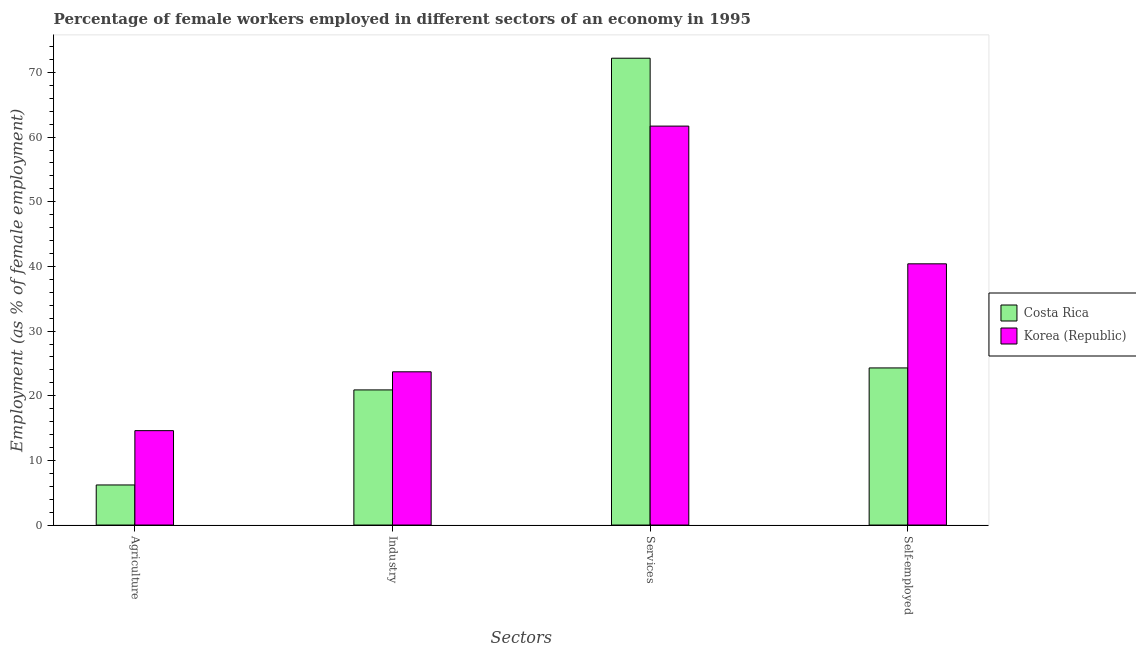How many groups of bars are there?
Your answer should be very brief. 4. Are the number of bars on each tick of the X-axis equal?
Your response must be concise. Yes. How many bars are there on the 2nd tick from the left?
Your answer should be compact. 2. How many bars are there on the 1st tick from the right?
Give a very brief answer. 2. What is the label of the 2nd group of bars from the left?
Provide a short and direct response. Industry. What is the percentage of female workers in services in Costa Rica?
Provide a succinct answer. 72.2. Across all countries, what is the maximum percentage of female workers in agriculture?
Ensure brevity in your answer.  14.6. Across all countries, what is the minimum percentage of female workers in industry?
Keep it short and to the point. 20.9. In which country was the percentage of self employed female workers minimum?
Offer a very short reply. Costa Rica. What is the total percentage of female workers in agriculture in the graph?
Your answer should be compact. 20.8. What is the difference between the percentage of self employed female workers in Korea (Republic) and that in Costa Rica?
Ensure brevity in your answer.  16.1. What is the difference between the percentage of self employed female workers in Costa Rica and the percentage of female workers in industry in Korea (Republic)?
Provide a short and direct response. 0.6. What is the average percentage of female workers in agriculture per country?
Your answer should be very brief. 10.4. What is the difference between the percentage of female workers in services and percentage of female workers in agriculture in Costa Rica?
Provide a succinct answer. 66. What is the ratio of the percentage of female workers in agriculture in Korea (Republic) to that in Costa Rica?
Provide a short and direct response. 2.35. Is the percentage of self employed female workers in Costa Rica less than that in Korea (Republic)?
Provide a succinct answer. Yes. What is the difference between the highest and the second highest percentage of female workers in industry?
Make the answer very short. 2.8. What is the difference between the highest and the lowest percentage of female workers in services?
Ensure brevity in your answer.  10.5. In how many countries, is the percentage of self employed female workers greater than the average percentage of self employed female workers taken over all countries?
Ensure brevity in your answer.  1. Is the sum of the percentage of female workers in services in Korea (Republic) and Costa Rica greater than the maximum percentage of female workers in agriculture across all countries?
Your response must be concise. Yes. Is it the case that in every country, the sum of the percentage of female workers in services and percentage of female workers in industry is greater than the sum of percentage of self employed female workers and percentage of female workers in agriculture?
Keep it short and to the point. Yes. What does the 1st bar from the left in Industry represents?
Your answer should be very brief. Costa Rica. Is it the case that in every country, the sum of the percentage of female workers in agriculture and percentage of female workers in industry is greater than the percentage of female workers in services?
Your response must be concise. No. How many countries are there in the graph?
Give a very brief answer. 2. Does the graph contain any zero values?
Your response must be concise. No. Does the graph contain grids?
Your answer should be compact. No. How many legend labels are there?
Provide a short and direct response. 2. What is the title of the graph?
Offer a very short reply. Percentage of female workers employed in different sectors of an economy in 1995. Does "Japan" appear as one of the legend labels in the graph?
Give a very brief answer. No. What is the label or title of the X-axis?
Offer a terse response. Sectors. What is the label or title of the Y-axis?
Keep it short and to the point. Employment (as % of female employment). What is the Employment (as % of female employment) in Costa Rica in Agriculture?
Offer a very short reply. 6.2. What is the Employment (as % of female employment) of Korea (Republic) in Agriculture?
Keep it short and to the point. 14.6. What is the Employment (as % of female employment) of Costa Rica in Industry?
Ensure brevity in your answer.  20.9. What is the Employment (as % of female employment) of Korea (Republic) in Industry?
Keep it short and to the point. 23.7. What is the Employment (as % of female employment) of Costa Rica in Services?
Your response must be concise. 72.2. What is the Employment (as % of female employment) of Korea (Republic) in Services?
Offer a terse response. 61.7. What is the Employment (as % of female employment) in Costa Rica in Self-employed?
Give a very brief answer. 24.3. What is the Employment (as % of female employment) of Korea (Republic) in Self-employed?
Make the answer very short. 40.4. Across all Sectors, what is the maximum Employment (as % of female employment) of Costa Rica?
Provide a short and direct response. 72.2. Across all Sectors, what is the maximum Employment (as % of female employment) of Korea (Republic)?
Give a very brief answer. 61.7. Across all Sectors, what is the minimum Employment (as % of female employment) in Costa Rica?
Your answer should be very brief. 6.2. Across all Sectors, what is the minimum Employment (as % of female employment) in Korea (Republic)?
Your answer should be very brief. 14.6. What is the total Employment (as % of female employment) in Costa Rica in the graph?
Your answer should be very brief. 123.6. What is the total Employment (as % of female employment) of Korea (Republic) in the graph?
Ensure brevity in your answer.  140.4. What is the difference between the Employment (as % of female employment) of Costa Rica in Agriculture and that in Industry?
Your answer should be compact. -14.7. What is the difference between the Employment (as % of female employment) in Costa Rica in Agriculture and that in Services?
Make the answer very short. -66. What is the difference between the Employment (as % of female employment) in Korea (Republic) in Agriculture and that in Services?
Give a very brief answer. -47.1. What is the difference between the Employment (as % of female employment) of Costa Rica in Agriculture and that in Self-employed?
Your response must be concise. -18.1. What is the difference between the Employment (as % of female employment) of Korea (Republic) in Agriculture and that in Self-employed?
Ensure brevity in your answer.  -25.8. What is the difference between the Employment (as % of female employment) of Costa Rica in Industry and that in Services?
Keep it short and to the point. -51.3. What is the difference between the Employment (as % of female employment) in Korea (Republic) in Industry and that in Services?
Your response must be concise. -38. What is the difference between the Employment (as % of female employment) of Korea (Republic) in Industry and that in Self-employed?
Offer a terse response. -16.7. What is the difference between the Employment (as % of female employment) in Costa Rica in Services and that in Self-employed?
Provide a succinct answer. 47.9. What is the difference between the Employment (as % of female employment) in Korea (Republic) in Services and that in Self-employed?
Give a very brief answer. 21.3. What is the difference between the Employment (as % of female employment) in Costa Rica in Agriculture and the Employment (as % of female employment) in Korea (Republic) in Industry?
Make the answer very short. -17.5. What is the difference between the Employment (as % of female employment) in Costa Rica in Agriculture and the Employment (as % of female employment) in Korea (Republic) in Services?
Keep it short and to the point. -55.5. What is the difference between the Employment (as % of female employment) of Costa Rica in Agriculture and the Employment (as % of female employment) of Korea (Republic) in Self-employed?
Keep it short and to the point. -34.2. What is the difference between the Employment (as % of female employment) in Costa Rica in Industry and the Employment (as % of female employment) in Korea (Republic) in Services?
Your answer should be very brief. -40.8. What is the difference between the Employment (as % of female employment) of Costa Rica in Industry and the Employment (as % of female employment) of Korea (Republic) in Self-employed?
Your response must be concise. -19.5. What is the difference between the Employment (as % of female employment) in Costa Rica in Services and the Employment (as % of female employment) in Korea (Republic) in Self-employed?
Your answer should be very brief. 31.8. What is the average Employment (as % of female employment) of Costa Rica per Sectors?
Your answer should be compact. 30.9. What is the average Employment (as % of female employment) in Korea (Republic) per Sectors?
Offer a very short reply. 35.1. What is the difference between the Employment (as % of female employment) of Costa Rica and Employment (as % of female employment) of Korea (Republic) in Agriculture?
Keep it short and to the point. -8.4. What is the difference between the Employment (as % of female employment) of Costa Rica and Employment (as % of female employment) of Korea (Republic) in Services?
Offer a very short reply. 10.5. What is the difference between the Employment (as % of female employment) of Costa Rica and Employment (as % of female employment) of Korea (Republic) in Self-employed?
Ensure brevity in your answer.  -16.1. What is the ratio of the Employment (as % of female employment) of Costa Rica in Agriculture to that in Industry?
Your response must be concise. 0.3. What is the ratio of the Employment (as % of female employment) in Korea (Republic) in Agriculture to that in Industry?
Make the answer very short. 0.62. What is the ratio of the Employment (as % of female employment) in Costa Rica in Agriculture to that in Services?
Your response must be concise. 0.09. What is the ratio of the Employment (as % of female employment) of Korea (Republic) in Agriculture to that in Services?
Ensure brevity in your answer.  0.24. What is the ratio of the Employment (as % of female employment) of Costa Rica in Agriculture to that in Self-employed?
Make the answer very short. 0.26. What is the ratio of the Employment (as % of female employment) in Korea (Republic) in Agriculture to that in Self-employed?
Provide a short and direct response. 0.36. What is the ratio of the Employment (as % of female employment) in Costa Rica in Industry to that in Services?
Your response must be concise. 0.29. What is the ratio of the Employment (as % of female employment) of Korea (Republic) in Industry to that in Services?
Keep it short and to the point. 0.38. What is the ratio of the Employment (as % of female employment) of Costa Rica in Industry to that in Self-employed?
Your answer should be compact. 0.86. What is the ratio of the Employment (as % of female employment) of Korea (Republic) in Industry to that in Self-employed?
Provide a short and direct response. 0.59. What is the ratio of the Employment (as % of female employment) of Costa Rica in Services to that in Self-employed?
Provide a short and direct response. 2.97. What is the ratio of the Employment (as % of female employment) in Korea (Republic) in Services to that in Self-employed?
Provide a short and direct response. 1.53. What is the difference between the highest and the second highest Employment (as % of female employment) in Costa Rica?
Make the answer very short. 47.9. What is the difference between the highest and the second highest Employment (as % of female employment) of Korea (Republic)?
Your response must be concise. 21.3. What is the difference between the highest and the lowest Employment (as % of female employment) of Costa Rica?
Give a very brief answer. 66. What is the difference between the highest and the lowest Employment (as % of female employment) of Korea (Republic)?
Provide a short and direct response. 47.1. 